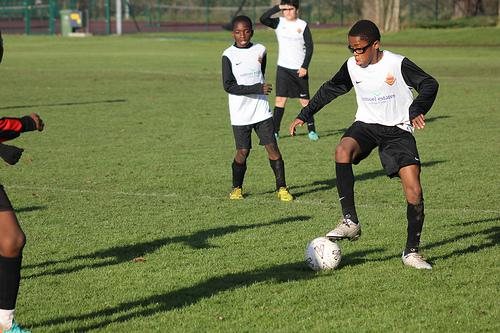Question: why was this photo taken?
Choices:
A. For a magazine.
B. For personal reasons.
C. For a newsletter.
D. For sale to highest bidder.
Answer with the letter. Answer: C Question: where was this photo taken?
Choices:
A. The beach.
B. A swimming pool.
C. The park.
D. A garden.
Answer with the letter. Answer: C Question: what season was this photo taken?
Choices:
A. Spring.
B. Fall.
C. Winter.
D. Summer.
Answer with the letter. Answer: D 